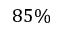Convert formula to latex. <formula><loc_0><loc_0><loc_500><loc_500>8 5 \%</formula> 